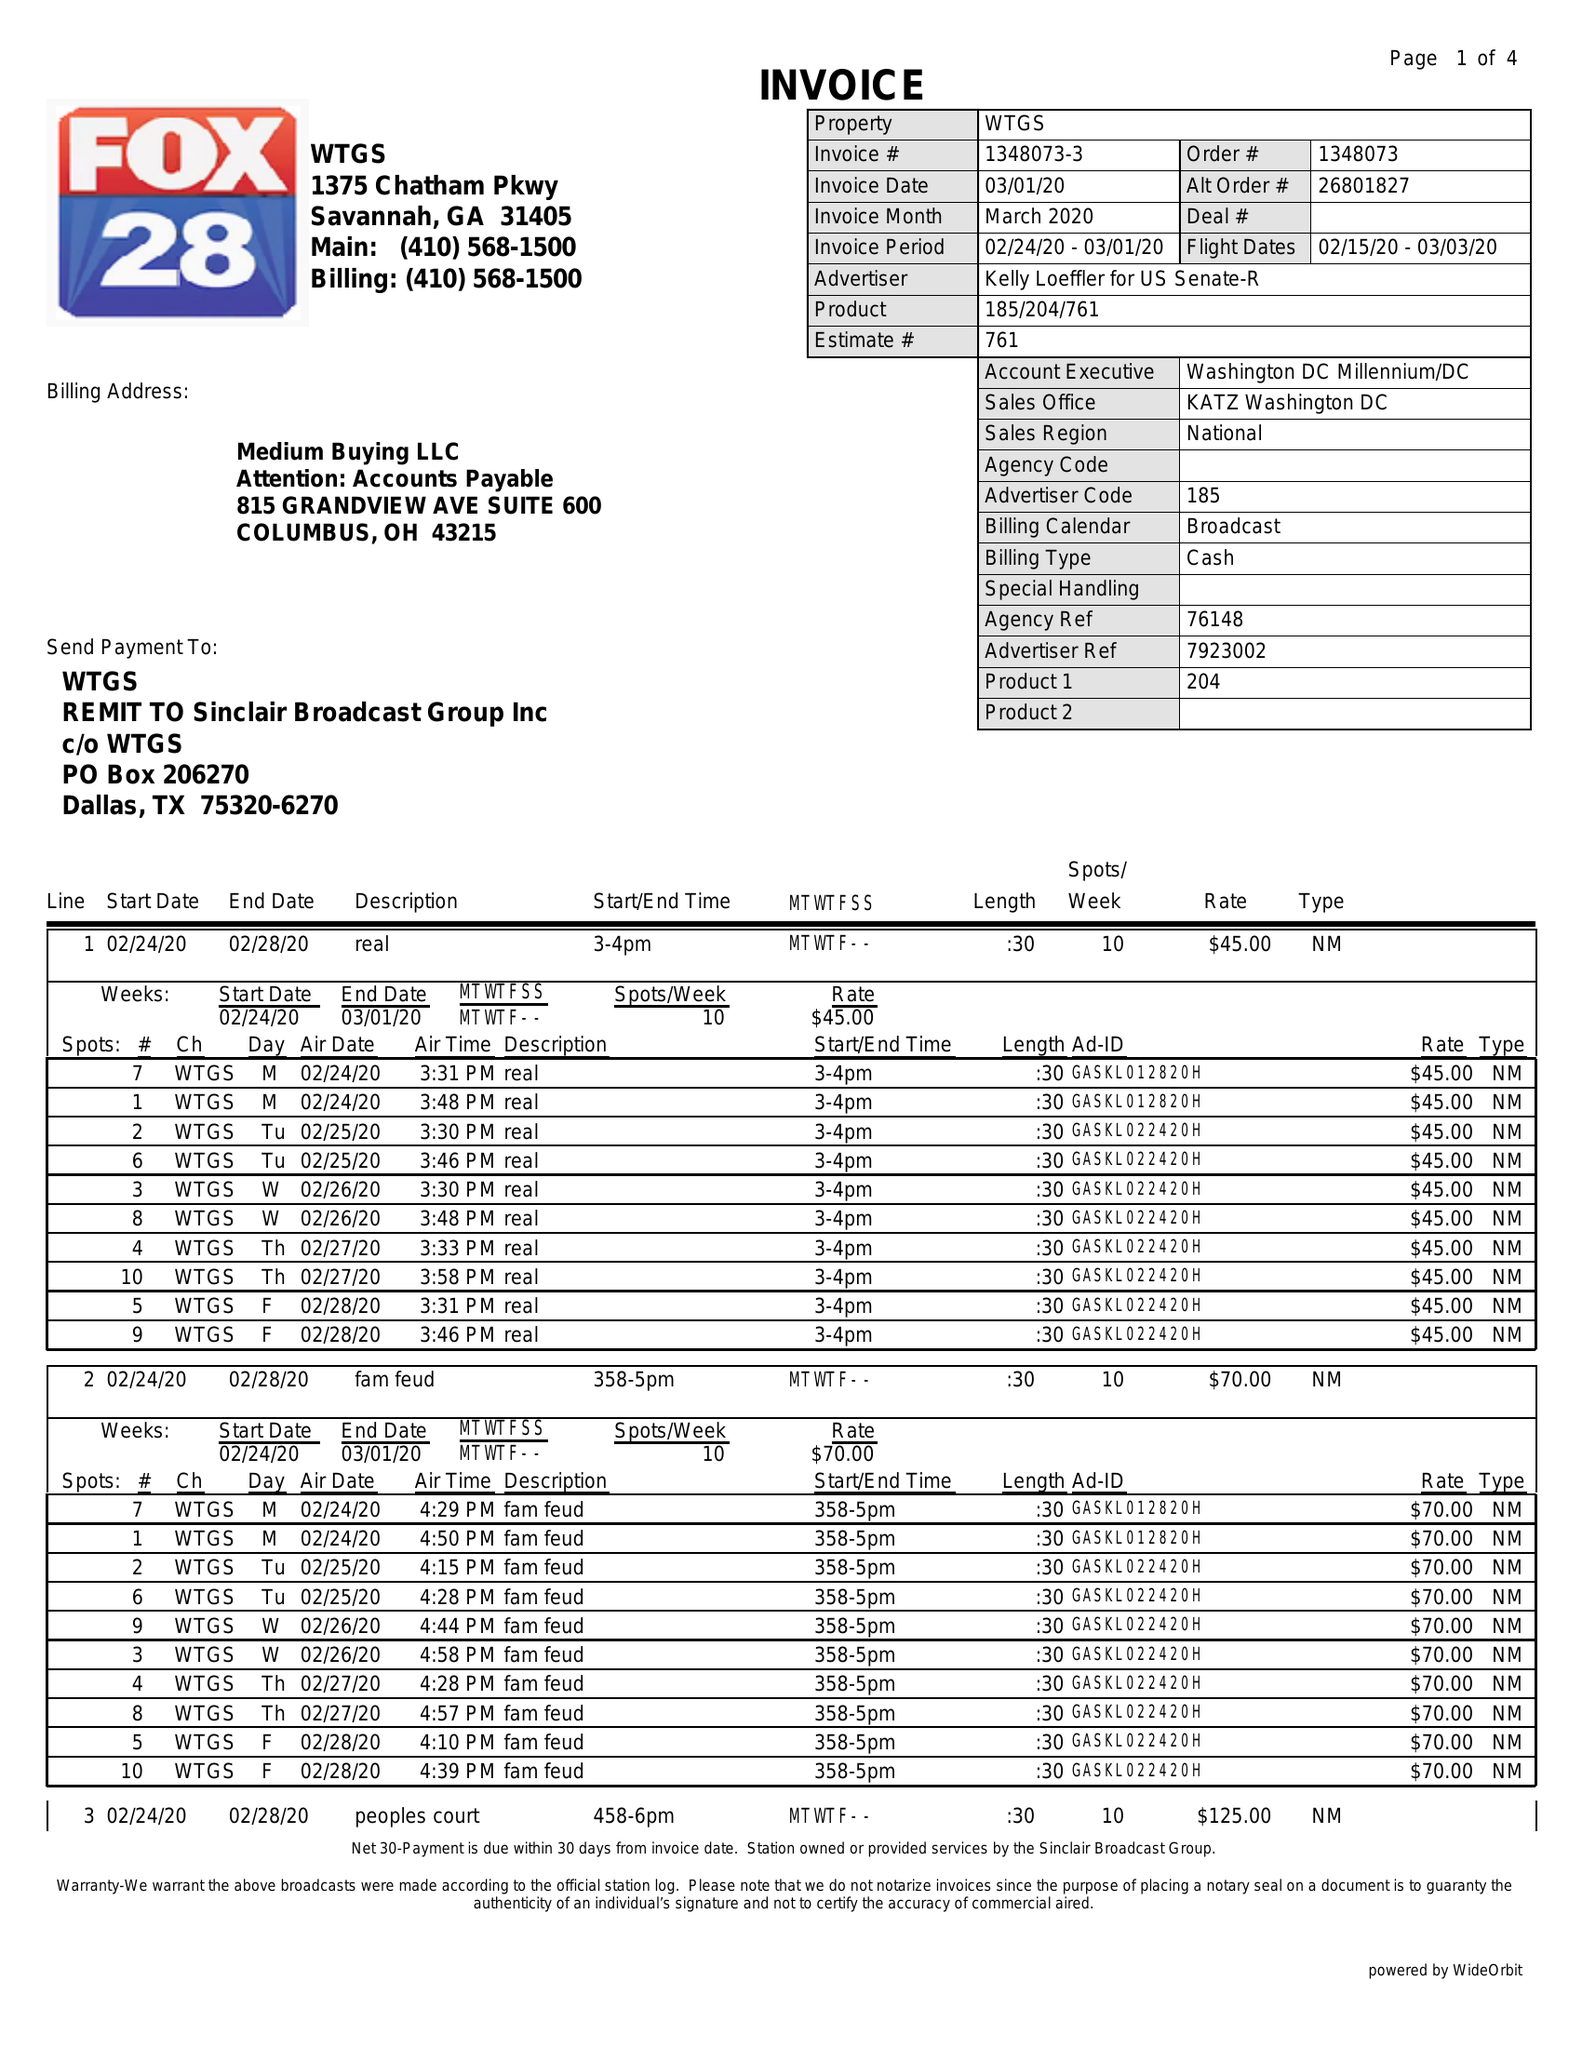What is the value for the contract_num?
Answer the question using a single word or phrase. 1348073 